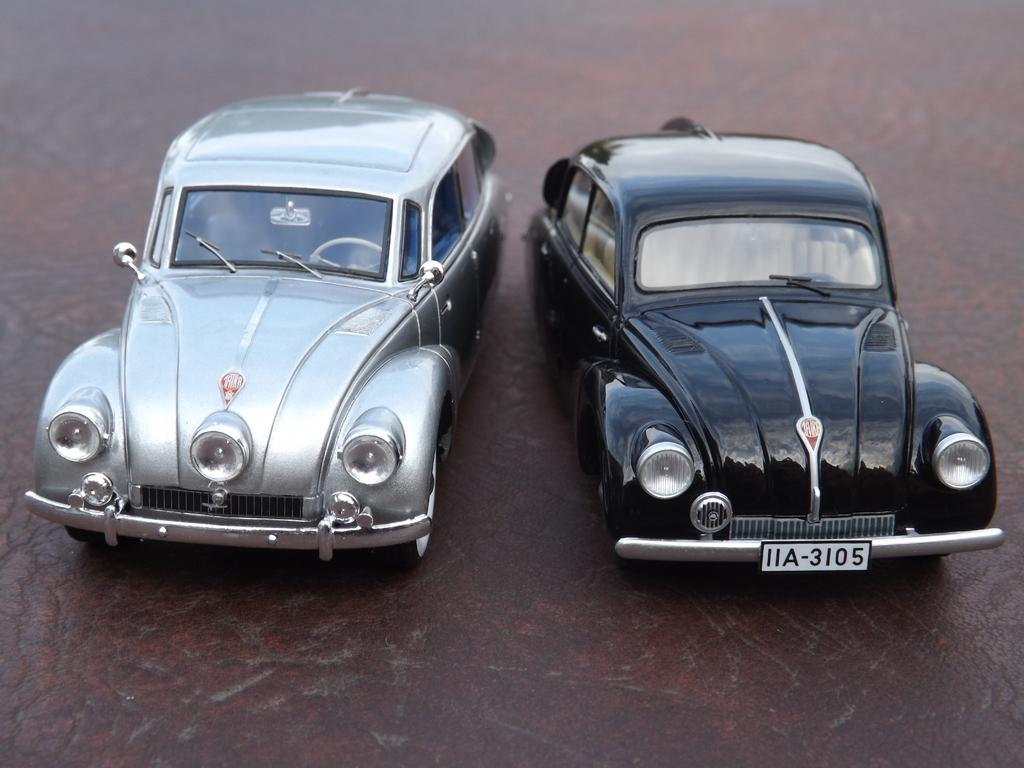How many cars are visible in the image? There are two cars in the image. What is present on one of the cars? There is a registration plate on one of the cars. What can be found on the registration plate? Text is written on the registration plate. What type of potato is being used to paint the cars in the image? There is no potato or painting activity present in the image; it only features two cars with a registration plate on one of them. 